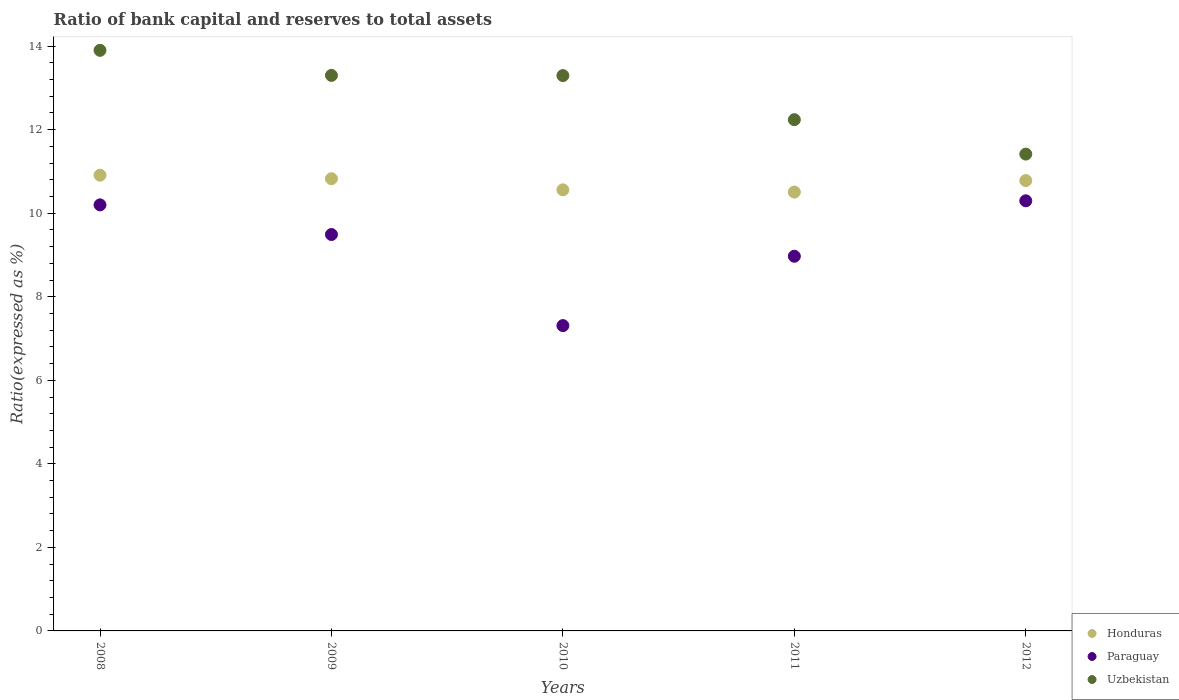How many different coloured dotlines are there?
Keep it short and to the point. 3. Is the number of dotlines equal to the number of legend labels?
Make the answer very short. Yes. What is the ratio of bank capital and reserves to total assets in Honduras in 2010?
Provide a short and direct response. 10.56. Across all years, what is the maximum ratio of bank capital and reserves to total assets in Honduras?
Keep it short and to the point. 10.91. Across all years, what is the minimum ratio of bank capital and reserves to total assets in Paraguay?
Provide a short and direct response. 7.31. In which year was the ratio of bank capital and reserves to total assets in Paraguay maximum?
Your response must be concise. 2012. What is the total ratio of bank capital and reserves to total assets in Honduras in the graph?
Keep it short and to the point. 53.59. What is the difference between the ratio of bank capital and reserves to total assets in Paraguay in 2008 and that in 2010?
Give a very brief answer. 2.89. What is the difference between the ratio of bank capital and reserves to total assets in Paraguay in 2008 and the ratio of bank capital and reserves to total assets in Uzbekistan in 2010?
Ensure brevity in your answer.  -3.1. What is the average ratio of bank capital and reserves to total assets in Honduras per year?
Provide a succinct answer. 10.72. In the year 2010, what is the difference between the ratio of bank capital and reserves to total assets in Honduras and ratio of bank capital and reserves to total assets in Paraguay?
Provide a succinct answer. 3.25. In how many years, is the ratio of bank capital and reserves to total assets in Uzbekistan greater than 11.6 %?
Your response must be concise. 4. What is the ratio of the ratio of bank capital and reserves to total assets in Paraguay in 2009 to that in 2012?
Ensure brevity in your answer.  0.92. Is the ratio of bank capital and reserves to total assets in Paraguay in 2008 less than that in 2011?
Ensure brevity in your answer.  No. Is the difference between the ratio of bank capital and reserves to total assets in Honduras in 2010 and 2012 greater than the difference between the ratio of bank capital and reserves to total assets in Paraguay in 2010 and 2012?
Make the answer very short. Yes. What is the difference between the highest and the second highest ratio of bank capital and reserves to total assets in Honduras?
Offer a terse response. 0.08. What is the difference between the highest and the lowest ratio of bank capital and reserves to total assets in Paraguay?
Give a very brief answer. 2.99. Is the sum of the ratio of bank capital and reserves to total assets in Uzbekistan in 2010 and 2012 greater than the maximum ratio of bank capital and reserves to total assets in Honduras across all years?
Your response must be concise. Yes. Does the ratio of bank capital and reserves to total assets in Honduras monotonically increase over the years?
Provide a short and direct response. No. Is the ratio of bank capital and reserves to total assets in Honduras strictly greater than the ratio of bank capital and reserves to total assets in Paraguay over the years?
Provide a succinct answer. Yes. How many dotlines are there?
Your answer should be very brief. 3. How many years are there in the graph?
Your answer should be compact. 5. What is the difference between two consecutive major ticks on the Y-axis?
Provide a short and direct response. 2. Does the graph contain any zero values?
Provide a succinct answer. No. Does the graph contain grids?
Provide a short and direct response. No. How many legend labels are there?
Give a very brief answer. 3. What is the title of the graph?
Your answer should be compact. Ratio of bank capital and reserves to total assets. What is the label or title of the Y-axis?
Give a very brief answer. Ratio(expressed as %). What is the Ratio(expressed as %) of Honduras in 2008?
Your answer should be compact. 10.91. What is the Ratio(expressed as %) of Honduras in 2009?
Give a very brief answer. 10.83. What is the Ratio(expressed as %) of Paraguay in 2009?
Your answer should be very brief. 9.49. What is the Ratio(expressed as %) in Honduras in 2010?
Ensure brevity in your answer.  10.56. What is the Ratio(expressed as %) of Paraguay in 2010?
Provide a short and direct response. 7.31. What is the Ratio(expressed as %) in Uzbekistan in 2010?
Your answer should be very brief. 13.3. What is the Ratio(expressed as %) of Honduras in 2011?
Your answer should be very brief. 10.51. What is the Ratio(expressed as %) of Paraguay in 2011?
Your answer should be compact. 8.97. What is the Ratio(expressed as %) in Uzbekistan in 2011?
Your answer should be compact. 12.24. What is the Ratio(expressed as %) of Honduras in 2012?
Make the answer very short. 10.78. What is the Ratio(expressed as %) in Paraguay in 2012?
Keep it short and to the point. 10.3. What is the Ratio(expressed as %) in Uzbekistan in 2012?
Your response must be concise. 11.42. Across all years, what is the maximum Ratio(expressed as %) of Honduras?
Offer a very short reply. 10.91. Across all years, what is the maximum Ratio(expressed as %) in Paraguay?
Give a very brief answer. 10.3. Across all years, what is the minimum Ratio(expressed as %) in Honduras?
Offer a terse response. 10.51. Across all years, what is the minimum Ratio(expressed as %) of Paraguay?
Offer a very short reply. 7.31. Across all years, what is the minimum Ratio(expressed as %) of Uzbekistan?
Offer a terse response. 11.42. What is the total Ratio(expressed as %) in Honduras in the graph?
Your response must be concise. 53.59. What is the total Ratio(expressed as %) of Paraguay in the graph?
Provide a short and direct response. 46.27. What is the total Ratio(expressed as %) in Uzbekistan in the graph?
Offer a very short reply. 64.15. What is the difference between the Ratio(expressed as %) of Honduras in 2008 and that in 2009?
Make the answer very short. 0.08. What is the difference between the Ratio(expressed as %) of Paraguay in 2008 and that in 2009?
Your response must be concise. 0.71. What is the difference between the Ratio(expressed as %) of Uzbekistan in 2008 and that in 2009?
Offer a very short reply. 0.6. What is the difference between the Ratio(expressed as %) of Honduras in 2008 and that in 2010?
Offer a terse response. 0.35. What is the difference between the Ratio(expressed as %) in Paraguay in 2008 and that in 2010?
Keep it short and to the point. 2.89. What is the difference between the Ratio(expressed as %) of Uzbekistan in 2008 and that in 2010?
Offer a very short reply. 0.6. What is the difference between the Ratio(expressed as %) of Honduras in 2008 and that in 2011?
Your response must be concise. 0.4. What is the difference between the Ratio(expressed as %) of Paraguay in 2008 and that in 2011?
Give a very brief answer. 1.23. What is the difference between the Ratio(expressed as %) of Uzbekistan in 2008 and that in 2011?
Make the answer very short. 1.66. What is the difference between the Ratio(expressed as %) in Honduras in 2008 and that in 2012?
Give a very brief answer. 0.13. What is the difference between the Ratio(expressed as %) in Paraguay in 2008 and that in 2012?
Keep it short and to the point. -0.1. What is the difference between the Ratio(expressed as %) in Uzbekistan in 2008 and that in 2012?
Offer a terse response. 2.48. What is the difference between the Ratio(expressed as %) in Honduras in 2009 and that in 2010?
Give a very brief answer. 0.27. What is the difference between the Ratio(expressed as %) of Paraguay in 2009 and that in 2010?
Offer a very short reply. 2.18. What is the difference between the Ratio(expressed as %) in Uzbekistan in 2009 and that in 2010?
Make the answer very short. 0. What is the difference between the Ratio(expressed as %) in Honduras in 2009 and that in 2011?
Make the answer very short. 0.32. What is the difference between the Ratio(expressed as %) in Paraguay in 2009 and that in 2011?
Keep it short and to the point. 0.52. What is the difference between the Ratio(expressed as %) in Uzbekistan in 2009 and that in 2011?
Give a very brief answer. 1.06. What is the difference between the Ratio(expressed as %) of Honduras in 2009 and that in 2012?
Give a very brief answer. 0.04. What is the difference between the Ratio(expressed as %) of Paraguay in 2009 and that in 2012?
Give a very brief answer. -0.81. What is the difference between the Ratio(expressed as %) in Uzbekistan in 2009 and that in 2012?
Offer a terse response. 1.88. What is the difference between the Ratio(expressed as %) in Honduras in 2010 and that in 2011?
Your answer should be very brief. 0.05. What is the difference between the Ratio(expressed as %) in Paraguay in 2010 and that in 2011?
Provide a succinct answer. -1.66. What is the difference between the Ratio(expressed as %) in Uzbekistan in 2010 and that in 2011?
Keep it short and to the point. 1.06. What is the difference between the Ratio(expressed as %) in Honduras in 2010 and that in 2012?
Provide a succinct answer. -0.22. What is the difference between the Ratio(expressed as %) of Paraguay in 2010 and that in 2012?
Provide a succinct answer. -2.99. What is the difference between the Ratio(expressed as %) in Uzbekistan in 2010 and that in 2012?
Make the answer very short. 1.88. What is the difference between the Ratio(expressed as %) of Honduras in 2011 and that in 2012?
Offer a very short reply. -0.28. What is the difference between the Ratio(expressed as %) of Paraguay in 2011 and that in 2012?
Offer a very short reply. -1.33. What is the difference between the Ratio(expressed as %) of Uzbekistan in 2011 and that in 2012?
Ensure brevity in your answer.  0.82. What is the difference between the Ratio(expressed as %) of Honduras in 2008 and the Ratio(expressed as %) of Paraguay in 2009?
Offer a terse response. 1.42. What is the difference between the Ratio(expressed as %) of Honduras in 2008 and the Ratio(expressed as %) of Uzbekistan in 2009?
Provide a succinct answer. -2.39. What is the difference between the Ratio(expressed as %) of Honduras in 2008 and the Ratio(expressed as %) of Paraguay in 2010?
Provide a short and direct response. 3.6. What is the difference between the Ratio(expressed as %) in Honduras in 2008 and the Ratio(expressed as %) in Uzbekistan in 2010?
Provide a short and direct response. -2.38. What is the difference between the Ratio(expressed as %) in Paraguay in 2008 and the Ratio(expressed as %) in Uzbekistan in 2010?
Provide a short and direct response. -3.1. What is the difference between the Ratio(expressed as %) in Honduras in 2008 and the Ratio(expressed as %) in Paraguay in 2011?
Give a very brief answer. 1.94. What is the difference between the Ratio(expressed as %) in Honduras in 2008 and the Ratio(expressed as %) in Uzbekistan in 2011?
Provide a short and direct response. -1.33. What is the difference between the Ratio(expressed as %) of Paraguay in 2008 and the Ratio(expressed as %) of Uzbekistan in 2011?
Keep it short and to the point. -2.04. What is the difference between the Ratio(expressed as %) of Honduras in 2008 and the Ratio(expressed as %) of Paraguay in 2012?
Your answer should be compact. 0.61. What is the difference between the Ratio(expressed as %) of Honduras in 2008 and the Ratio(expressed as %) of Uzbekistan in 2012?
Provide a succinct answer. -0.51. What is the difference between the Ratio(expressed as %) in Paraguay in 2008 and the Ratio(expressed as %) in Uzbekistan in 2012?
Keep it short and to the point. -1.22. What is the difference between the Ratio(expressed as %) of Honduras in 2009 and the Ratio(expressed as %) of Paraguay in 2010?
Your answer should be compact. 3.52. What is the difference between the Ratio(expressed as %) of Honduras in 2009 and the Ratio(expressed as %) of Uzbekistan in 2010?
Offer a very short reply. -2.47. What is the difference between the Ratio(expressed as %) of Paraguay in 2009 and the Ratio(expressed as %) of Uzbekistan in 2010?
Provide a short and direct response. -3.81. What is the difference between the Ratio(expressed as %) in Honduras in 2009 and the Ratio(expressed as %) in Paraguay in 2011?
Your answer should be compact. 1.86. What is the difference between the Ratio(expressed as %) of Honduras in 2009 and the Ratio(expressed as %) of Uzbekistan in 2011?
Offer a very short reply. -1.41. What is the difference between the Ratio(expressed as %) of Paraguay in 2009 and the Ratio(expressed as %) of Uzbekistan in 2011?
Give a very brief answer. -2.75. What is the difference between the Ratio(expressed as %) of Honduras in 2009 and the Ratio(expressed as %) of Paraguay in 2012?
Keep it short and to the point. 0.53. What is the difference between the Ratio(expressed as %) in Honduras in 2009 and the Ratio(expressed as %) in Uzbekistan in 2012?
Your response must be concise. -0.59. What is the difference between the Ratio(expressed as %) in Paraguay in 2009 and the Ratio(expressed as %) in Uzbekistan in 2012?
Provide a short and direct response. -1.93. What is the difference between the Ratio(expressed as %) of Honduras in 2010 and the Ratio(expressed as %) of Paraguay in 2011?
Ensure brevity in your answer.  1.59. What is the difference between the Ratio(expressed as %) in Honduras in 2010 and the Ratio(expressed as %) in Uzbekistan in 2011?
Offer a very short reply. -1.68. What is the difference between the Ratio(expressed as %) in Paraguay in 2010 and the Ratio(expressed as %) in Uzbekistan in 2011?
Offer a very short reply. -4.93. What is the difference between the Ratio(expressed as %) of Honduras in 2010 and the Ratio(expressed as %) of Paraguay in 2012?
Make the answer very short. 0.26. What is the difference between the Ratio(expressed as %) of Honduras in 2010 and the Ratio(expressed as %) of Uzbekistan in 2012?
Give a very brief answer. -0.86. What is the difference between the Ratio(expressed as %) in Paraguay in 2010 and the Ratio(expressed as %) in Uzbekistan in 2012?
Make the answer very short. -4.11. What is the difference between the Ratio(expressed as %) in Honduras in 2011 and the Ratio(expressed as %) in Paraguay in 2012?
Offer a terse response. 0.21. What is the difference between the Ratio(expressed as %) of Honduras in 2011 and the Ratio(expressed as %) of Uzbekistan in 2012?
Give a very brief answer. -0.91. What is the difference between the Ratio(expressed as %) of Paraguay in 2011 and the Ratio(expressed as %) of Uzbekistan in 2012?
Your answer should be very brief. -2.45. What is the average Ratio(expressed as %) of Honduras per year?
Keep it short and to the point. 10.72. What is the average Ratio(expressed as %) in Paraguay per year?
Your answer should be very brief. 9.25. What is the average Ratio(expressed as %) in Uzbekistan per year?
Offer a terse response. 12.83. In the year 2008, what is the difference between the Ratio(expressed as %) in Honduras and Ratio(expressed as %) in Paraguay?
Make the answer very short. 0.71. In the year 2008, what is the difference between the Ratio(expressed as %) of Honduras and Ratio(expressed as %) of Uzbekistan?
Keep it short and to the point. -2.99. In the year 2008, what is the difference between the Ratio(expressed as %) in Paraguay and Ratio(expressed as %) in Uzbekistan?
Provide a succinct answer. -3.7. In the year 2009, what is the difference between the Ratio(expressed as %) in Honduras and Ratio(expressed as %) in Paraguay?
Provide a succinct answer. 1.34. In the year 2009, what is the difference between the Ratio(expressed as %) of Honduras and Ratio(expressed as %) of Uzbekistan?
Provide a succinct answer. -2.47. In the year 2009, what is the difference between the Ratio(expressed as %) in Paraguay and Ratio(expressed as %) in Uzbekistan?
Give a very brief answer. -3.81. In the year 2010, what is the difference between the Ratio(expressed as %) of Honduras and Ratio(expressed as %) of Paraguay?
Provide a short and direct response. 3.25. In the year 2010, what is the difference between the Ratio(expressed as %) of Honduras and Ratio(expressed as %) of Uzbekistan?
Provide a short and direct response. -2.74. In the year 2010, what is the difference between the Ratio(expressed as %) in Paraguay and Ratio(expressed as %) in Uzbekistan?
Provide a succinct answer. -5.99. In the year 2011, what is the difference between the Ratio(expressed as %) in Honduras and Ratio(expressed as %) in Paraguay?
Make the answer very short. 1.54. In the year 2011, what is the difference between the Ratio(expressed as %) in Honduras and Ratio(expressed as %) in Uzbekistan?
Ensure brevity in your answer.  -1.73. In the year 2011, what is the difference between the Ratio(expressed as %) in Paraguay and Ratio(expressed as %) in Uzbekistan?
Provide a succinct answer. -3.27. In the year 2012, what is the difference between the Ratio(expressed as %) in Honduras and Ratio(expressed as %) in Paraguay?
Keep it short and to the point. 0.48. In the year 2012, what is the difference between the Ratio(expressed as %) of Honduras and Ratio(expressed as %) of Uzbekistan?
Your response must be concise. -0.63. In the year 2012, what is the difference between the Ratio(expressed as %) in Paraguay and Ratio(expressed as %) in Uzbekistan?
Give a very brief answer. -1.12. What is the ratio of the Ratio(expressed as %) in Honduras in 2008 to that in 2009?
Give a very brief answer. 1.01. What is the ratio of the Ratio(expressed as %) in Paraguay in 2008 to that in 2009?
Keep it short and to the point. 1.07. What is the ratio of the Ratio(expressed as %) in Uzbekistan in 2008 to that in 2009?
Give a very brief answer. 1.05. What is the ratio of the Ratio(expressed as %) in Honduras in 2008 to that in 2010?
Your answer should be very brief. 1.03. What is the ratio of the Ratio(expressed as %) in Paraguay in 2008 to that in 2010?
Offer a very short reply. 1.4. What is the ratio of the Ratio(expressed as %) of Uzbekistan in 2008 to that in 2010?
Offer a terse response. 1.05. What is the ratio of the Ratio(expressed as %) of Paraguay in 2008 to that in 2011?
Your answer should be very brief. 1.14. What is the ratio of the Ratio(expressed as %) in Uzbekistan in 2008 to that in 2011?
Keep it short and to the point. 1.14. What is the ratio of the Ratio(expressed as %) of Paraguay in 2008 to that in 2012?
Your response must be concise. 0.99. What is the ratio of the Ratio(expressed as %) in Uzbekistan in 2008 to that in 2012?
Your response must be concise. 1.22. What is the ratio of the Ratio(expressed as %) of Honduras in 2009 to that in 2010?
Make the answer very short. 1.03. What is the ratio of the Ratio(expressed as %) of Paraguay in 2009 to that in 2010?
Make the answer very short. 1.3. What is the ratio of the Ratio(expressed as %) of Uzbekistan in 2009 to that in 2010?
Offer a terse response. 1. What is the ratio of the Ratio(expressed as %) in Honduras in 2009 to that in 2011?
Ensure brevity in your answer.  1.03. What is the ratio of the Ratio(expressed as %) in Paraguay in 2009 to that in 2011?
Your response must be concise. 1.06. What is the ratio of the Ratio(expressed as %) in Uzbekistan in 2009 to that in 2011?
Offer a terse response. 1.09. What is the ratio of the Ratio(expressed as %) in Honduras in 2009 to that in 2012?
Provide a succinct answer. 1. What is the ratio of the Ratio(expressed as %) in Paraguay in 2009 to that in 2012?
Ensure brevity in your answer.  0.92. What is the ratio of the Ratio(expressed as %) in Uzbekistan in 2009 to that in 2012?
Your answer should be compact. 1.17. What is the ratio of the Ratio(expressed as %) of Honduras in 2010 to that in 2011?
Your response must be concise. 1.01. What is the ratio of the Ratio(expressed as %) of Paraguay in 2010 to that in 2011?
Keep it short and to the point. 0.81. What is the ratio of the Ratio(expressed as %) in Uzbekistan in 2010 to that in 2011?
Provide a short and direct response. 1.09. What is the ratio of the Ratio(expressed as %) of Honduras in 2010 to that in 2012?
Provide a succinct answer. 0.98. What is the ratio of the Ratio(expressed as %) of Paraguay in 2010 to that in 2012?
Make the answer very short. 0.71. What is the ratio of the Ratio(expressed as %) of Uzbekistan in 2010 to that in 2012?
Make the answer very short. 1.16. What is the ratio of the Ratio(expressed as %) in Honduras in 2011 to that in 2012?
Provide a short and direct response. 0.97. What is the ratio of the Ratio(expressed as %) in Paraguay in 2011 to that in 2012?
Provide a succinct answer. 0.87. What is the ratio of the Ratio(expressed as %) in Uzbekistan in 2011 to that in 2012?
Give a very brief answer. 1.07. What is the difference between the highest and the second highest Ratio(expressed as %) of Honduras?
Ensure brevity in your answer.  0.08. What is the difference between the highest and the second highest Ratio(expressed as %) of Paraguay?
Ensure brevity in your answer.  0.1. What is the difference between the highest and the lowest Ratio(expressed as %) of Honduras?
Keep it short and to the point. 0.4. What is the difference between the highest and the lowest Ratio(expressed as %) in Paraguay?
Provide a short and direct response. 2.99. What is the difference between the highest and the lowest Ratio(expressed as %) in Uzbekistan?
Provide a short and direct response. 2.48. 